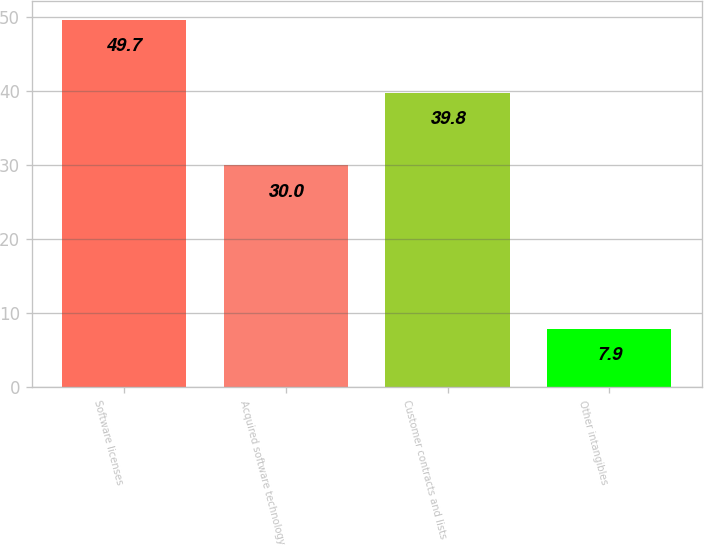Convert chart to OTSL. <chart><loc_0><loc_0><loc_500><loc_500><bar_chart><fcel>Software licenses<fcel>Acquired software technology<fcel>Customer contracts and lists<fcel>Other intangibles<nl><fcel>49.7<fcel>30<fcel>39.8<fcel>7.9<nl></chart> 